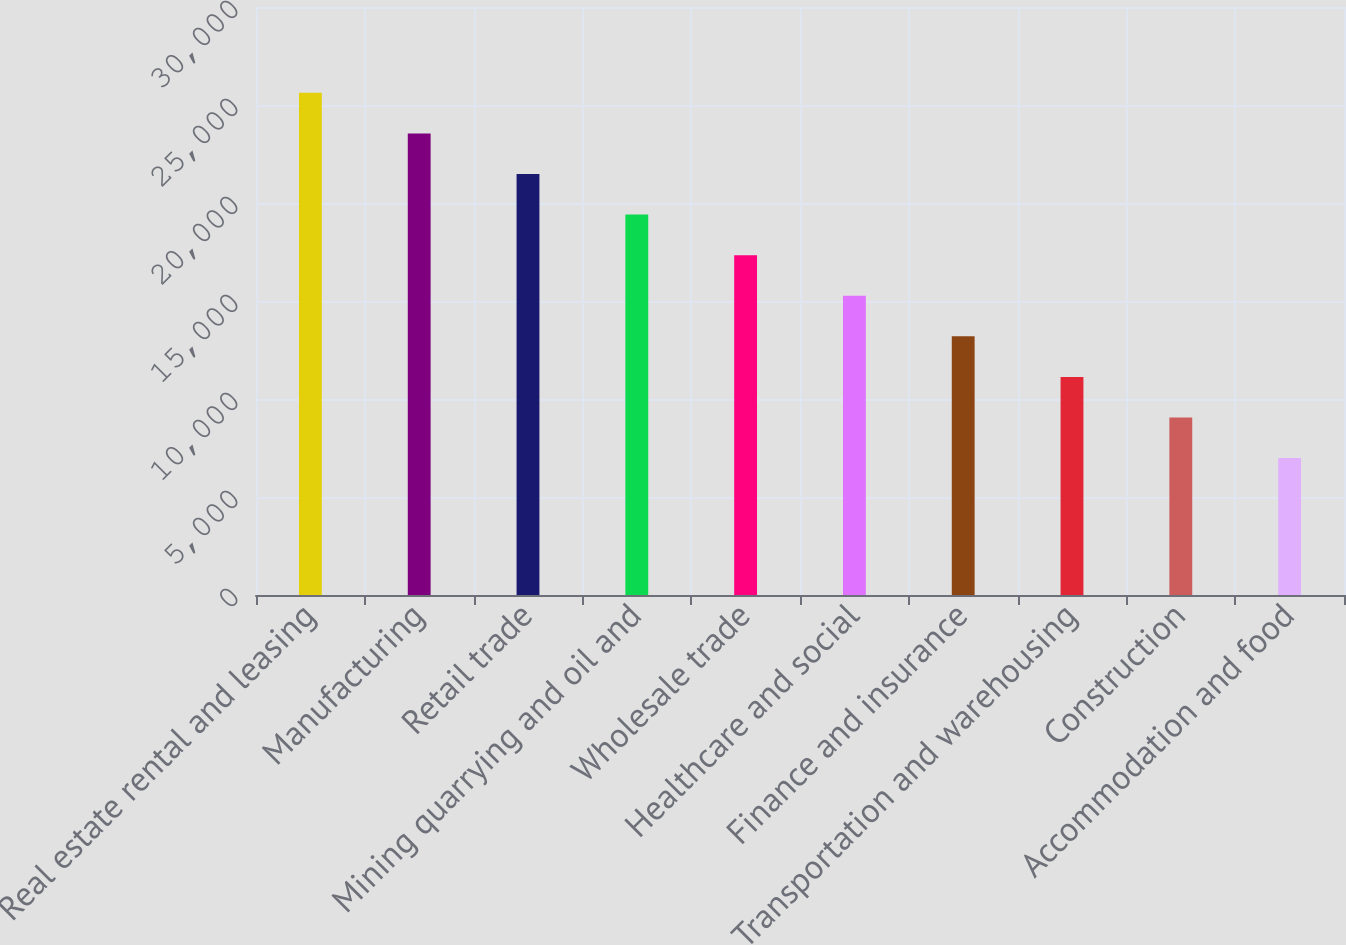Convert chart to OTSL. <chart><loc_0><loc_0><loc_500><loc_500><bar_chart><fcel>Real estate rental and leasing<fcel>Manufacturing<fcel>Retail trade<fcel>Mining quarrying and oil and<fcel>Wholesale trade<fcel>Healthcare and social<fcel>Finance and insurance<fcel>Transportation and warehousing<fcel>Construction<fcel>Accommodation and food<nl><fcel>25619.8<fcel>23549.4<fcel>21479<fcel>19408.6<fcel>17338.2<fcel>15267.8<fcel>13197.4<fcel>11127<fcel>9056.6<fcel>6986.2<nl></chart> 